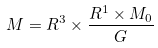<formula> <loc_0><loc_0><loc_500><loc_500>M = R ^ { 3 } \times \frac { R ^ { 1 } \times M _ { 0 } } { G }</formula> 